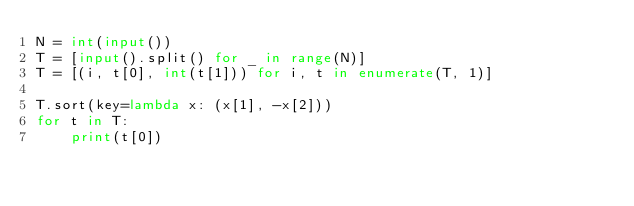<code> <loc_0><loc_0><loc_500><loc_500><_Python_>N = int(input())
T = [input().split() for _ in range(N)]
T = [(i, t[0], int(t[1])) for i, t in enumerate(T, 1)]

T.sort(key=lambda x: (x[1], -x[2]))
for t in T:
    print(t[0])
</code> 